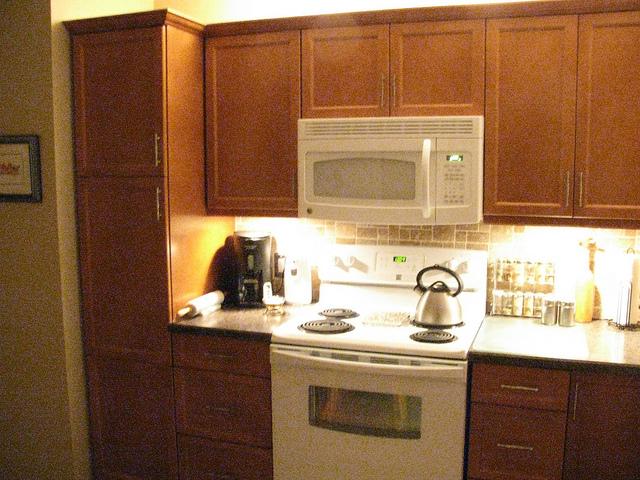Do you see any knives?
Quick response, please. No. Can you make coffee in this kitchen?
Be succinct. Yes. Is the stove black?
Short answer required. No. What color are the cabinets?
Be succinct. Brown. What is the purpose of the item to the far left?
Answer briefly. Make coffee. Does the color of the microwave match the stove?
Write a very short answer. Yes. Is the stove gas or electric?
Give a very brief answer. Electric. 